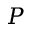<formula> <loc_0><loc_0><loc_500><loc_500>P</formula> 